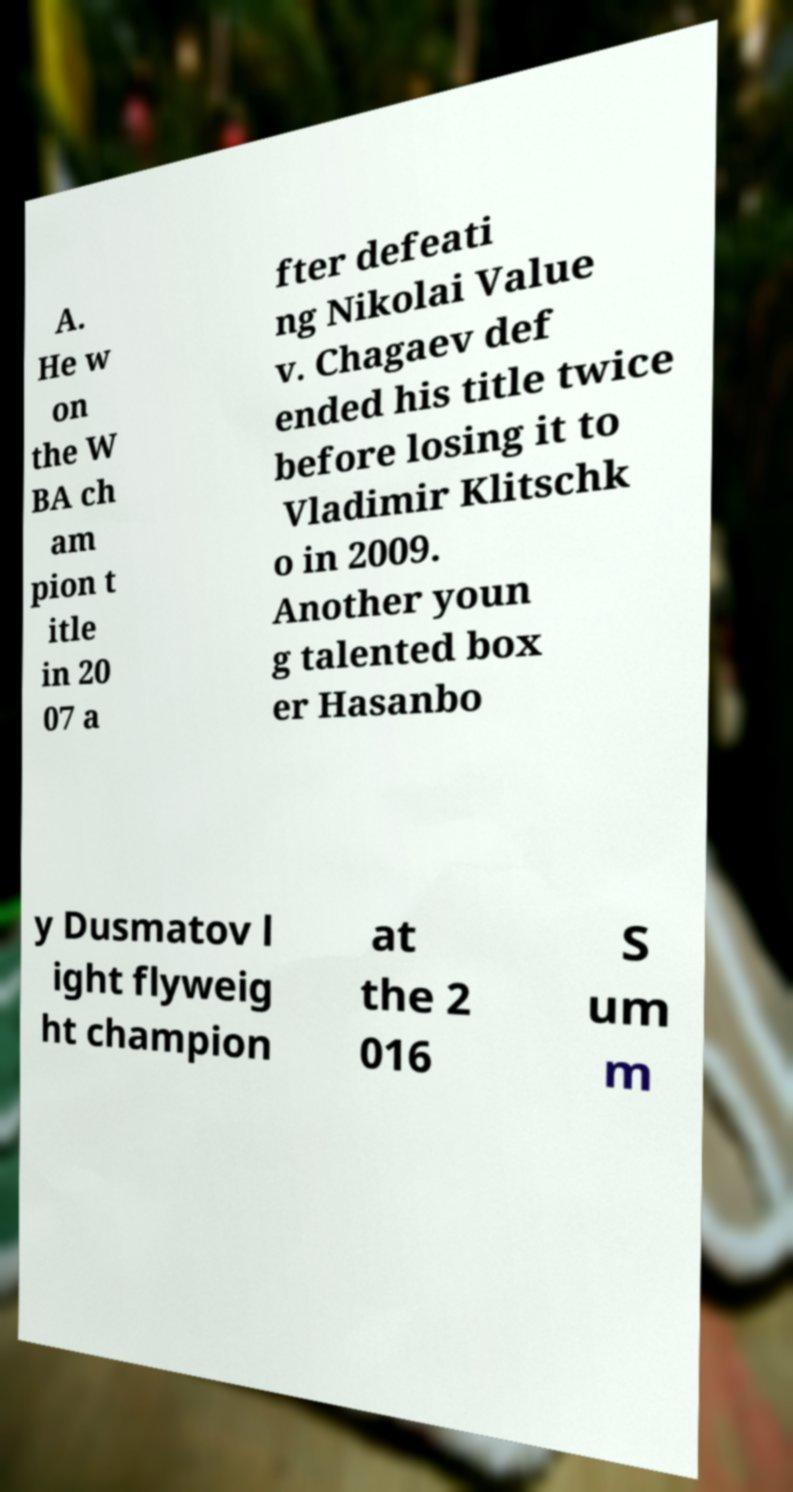Could you assist in decoding the text presented in this image and type it out clearly? A. He w on the W BA ch am pion t itle in 20 07 a fter defeati ng Nikolai Value v. Chagaev def ended his title twice before losing it to Vladimir Klitschk o in 2009. Another youn g talented box er Hasanbo y Dusmatov l ight flyweig ht champion at the 2 016 S um m 